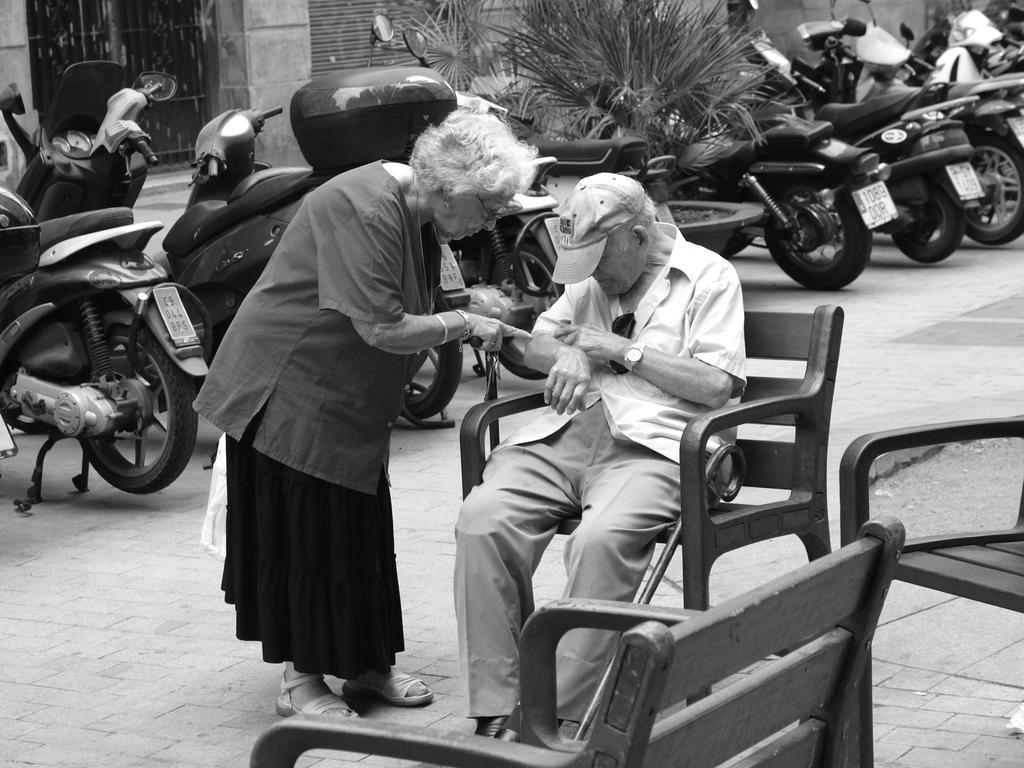Can you describe this image briefly? In this image I can see two persons. In front the person is sitting on the chair and I can see few chairs. In the background I can see few vehicles and plants and the image is in black and white. 